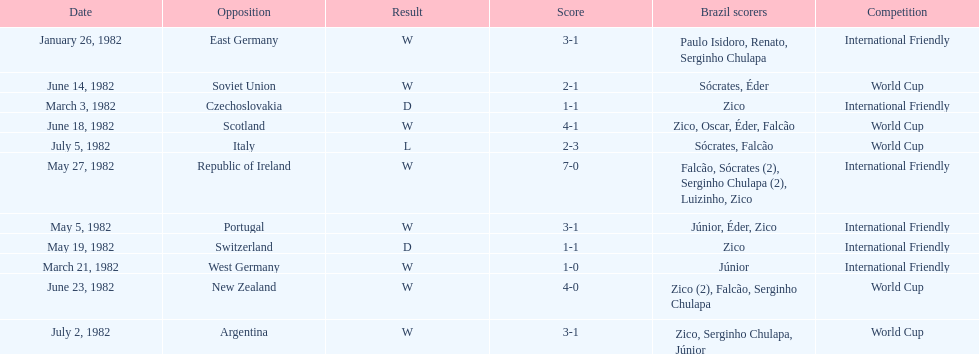Who was this team's next opponent after facing the soviet union on june 14? Scotland. 